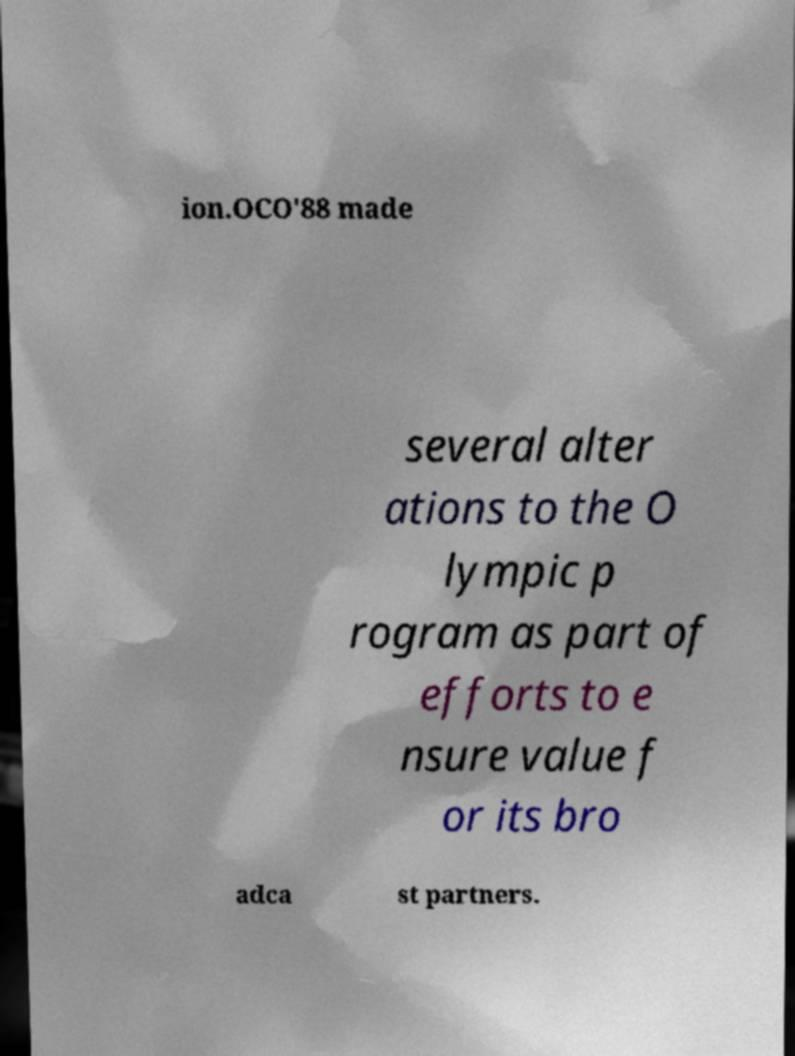There's text embedded in this image that I need extracted. Can you transcribe it verbatim? ion.OCO'88 made several alter ations to the O lympic p rogram as part of efforts to e nsure value f or its bro adca st partners. 